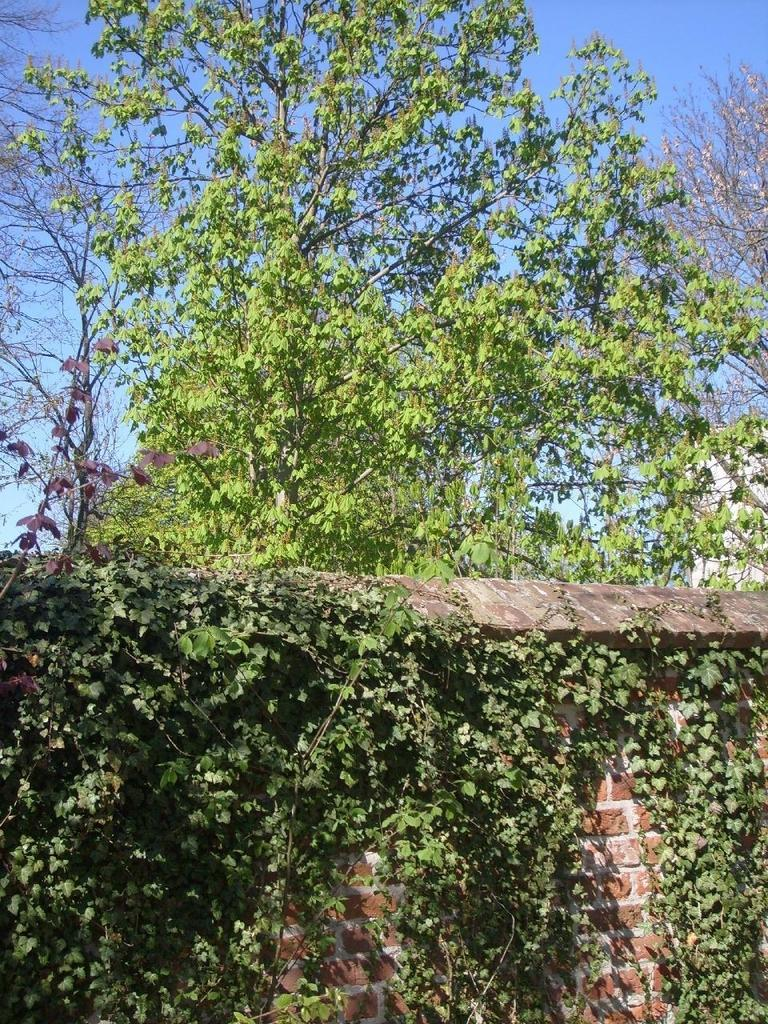What type of structure can be seen in the image? There is a wall in the image. What color are the plants in the image? The plants in the image are green in color. What is the color of the sky in the image? The sky is blue in the image. What type of dinner is being served in the image? There is no dinner present in the image; it features a wall, green plants, and a blue sky. What need is being fulfilled by the plants in the image? The plants in the image do not fulfill any specific need; they are simply part of the image's scenery. 